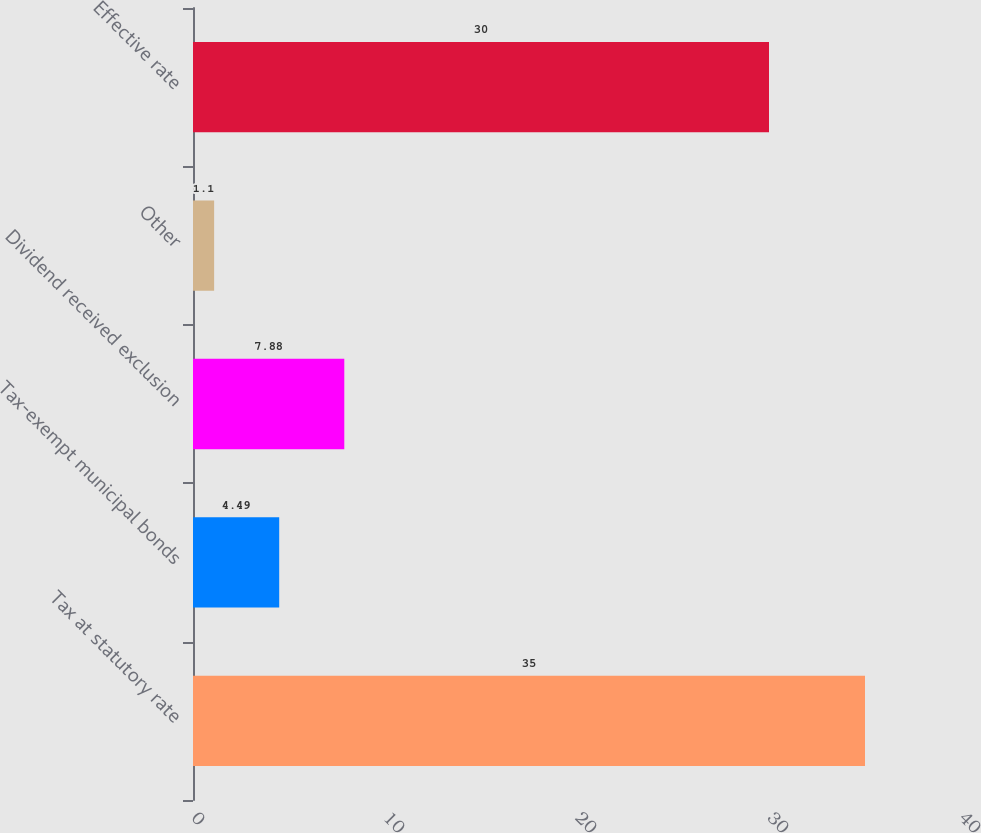Convert chart. <chart><loc_0><loc_0><loc_500><loc_500><bar_chart><fcel>Tax at statutory rate<fcel>Tax-exempt municipal bonds<fcel>Dividend received exclusion<fcel>Other<fcel>Effective rate<nl><fcel>35<fcel>4.49<fcel>7.88<fcel>1.1<fcel>30<nl></chart> 